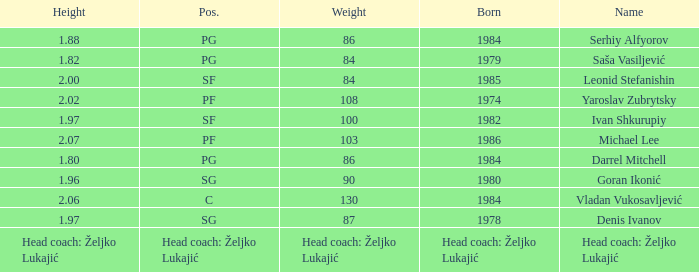Which position did Michael Lee play? PF. 